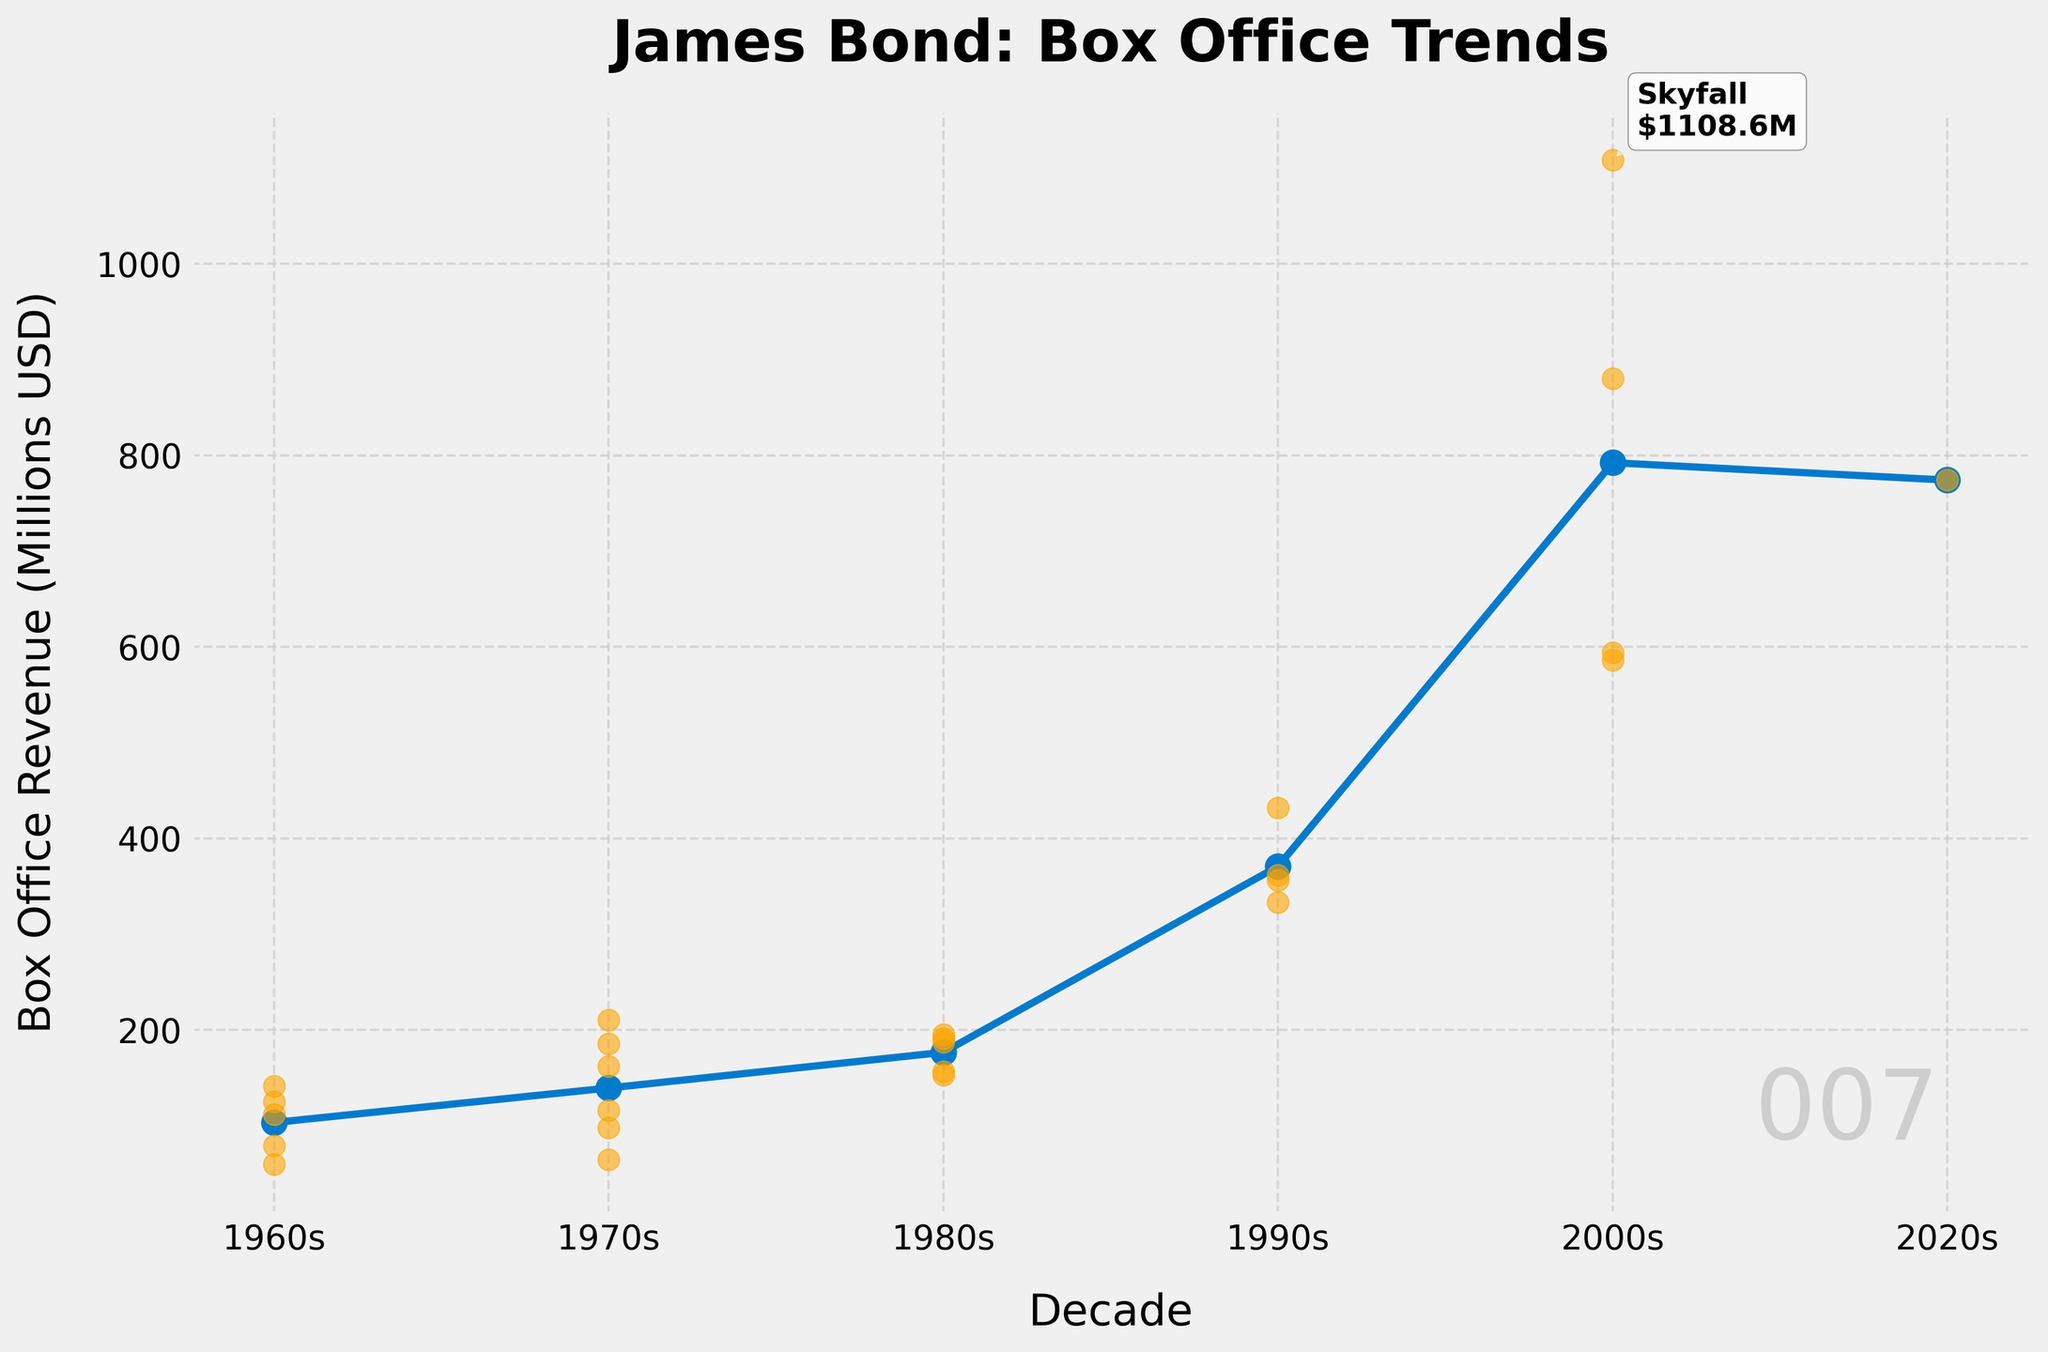what is the title of the plot? The title can be found at the top of the figure. It is in bold and provides an overview of the data presented.
Answer: James Bond: Box Office Trends Which decade has the highest average box office revenue? The highest average box office revenue is depicted by the line with a marker at the topmost position on the y-axis, considering all the points within a decade.
Answer: 2000s What is the box office revenue of "Skyfall"? Hover over the plotted points, and find a highlighted annotation. The highest grossing annotation indicates the revenue of "Skyfall".
Answer: 1108.60 million USD Which movie had the lowest box office revenue in the 1980s? Identify the scatter points in the 1980s. The lowest y-value within this range, which is the lowest box office revenue, helps you pinpoint the movie.
Answer: For Your Eyes Only How does the average box office revenue in the 1990s compare to the 1970s? Locate the markers for both the 1990s and the 1970s on the averaged line. Compare their y-axis positions to see which is higher.
Answer: The 1990s have a higher average revenue than the 1970s What movie marks the peak in revenue for the 1970s? Identify the movie with the highest single scatter point in the 1970s section.
Answer: Moonraker Which decade saw the greatest variance in movie revenues? Observe the spread and dispersion of scatter points within each decade. The decade with the widest spread indicates the greatest variance.
Answer: 2000s What trend can be observed in relation to box office revenue over the decades? Notice the successive positions of the averaged markers from the 1960s onwards. See if revenues tend to increase, decrease, or show some other pattern.
Answer: Increasing trend Which movie had a box office revenue of about 432 million USD and in which decade was it released? By examining the point roughly corresponding to 432 on the y-axis, identify the labeled movie in that range.
Answer: Die Another Day, 1990s How does the box office revenue of "Thunderball" compare to "From Russia with Love"? Look at the y-axis values for the respective scatter points of these two movies. Compare which one is higher.
Answer: Thunderball is higher 